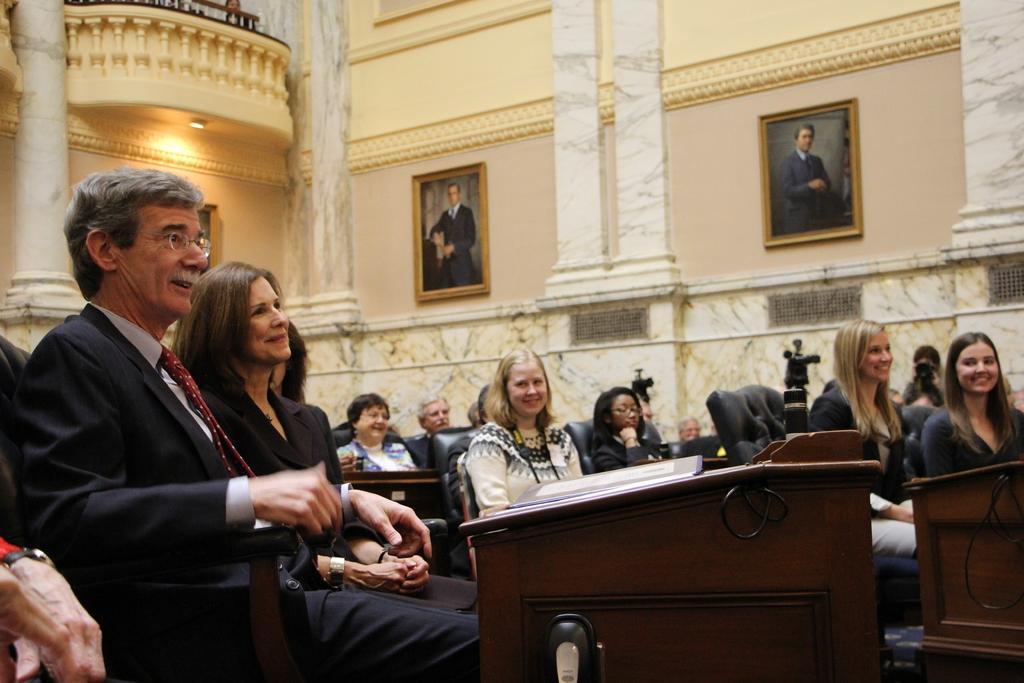Please provide a concise description of this image. In a room there are so many chairs and a table are arranged on it. On a table there are files and people are sitting on the chairs on the other side there are phone frames stick on wall in between the pillars and on the opposite side there is a balcony of the first floor. 